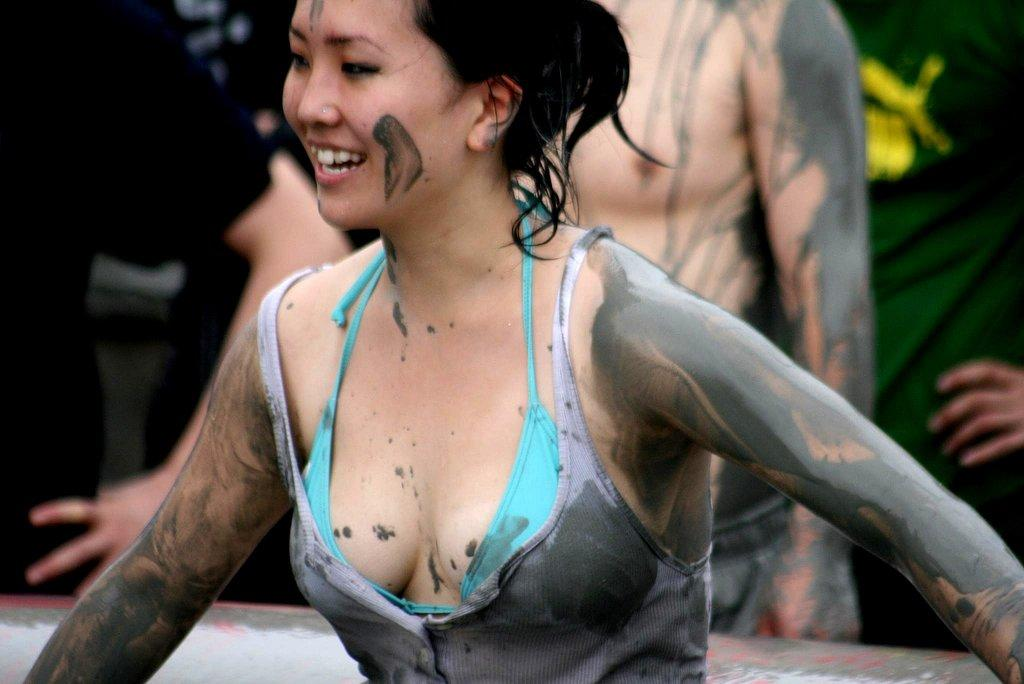Who is the main subject in the image? There is a woman in the image. Can you describe the background of the image? There are a few persons and an object in the background of the image. What type of corn can be seen growing in the image? There is no corn present in the image. How many fingers does the woman have in the image? The number of fingers the woman has cannot be determined from the image alone, as her hands are not visible. 